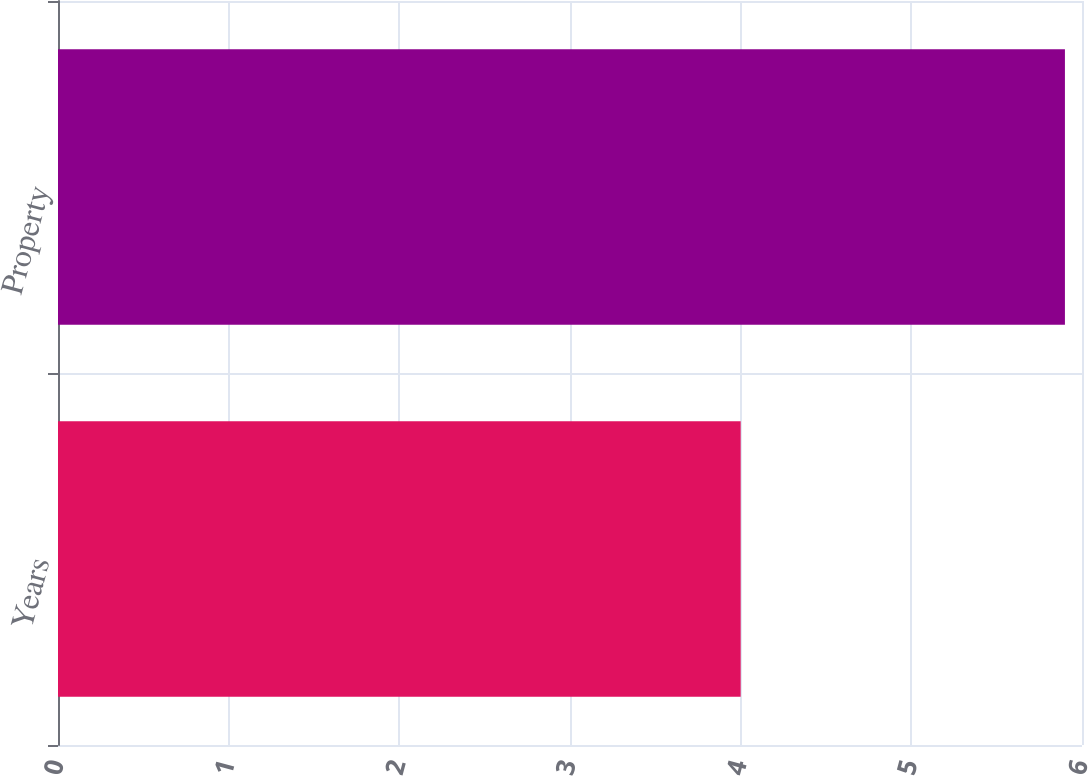Convert chart to OTSL. <chart><loc_0><loc_0><loc_500><loc_500><bar_chart><fcel>Years<fcel>Property<nl><fcel>4<fcel>5.9<nl></chart> 